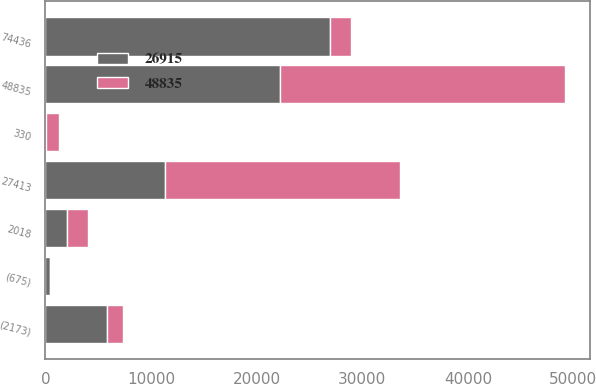Convert chart to OTSL. <chart><loc_0><loc_0><loc_500><loc_500><stacked_bar_chart><ecel><fcel>2018<fcel>48835<fcel>330<fcel>27413<fcel>(675)<fcel>(2173)<fcel>74436<nl><fcel>48835<fcel>2017<fcel>26915<fcel>1243<fcel>22202<fcel>21<fcel>1504<fcel>2017<nl><fcel>26915<fcel>2016<fcel>22239<fcel>46<fcel>11359<fcel>426<fcel>5871<fcel>26915<nl></chart> 